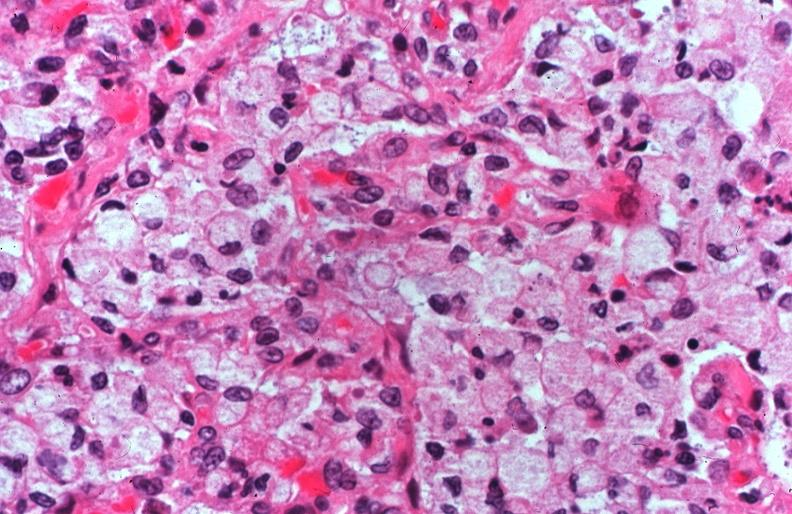where is this?
Answer the question using a single word or phrase. Lung 